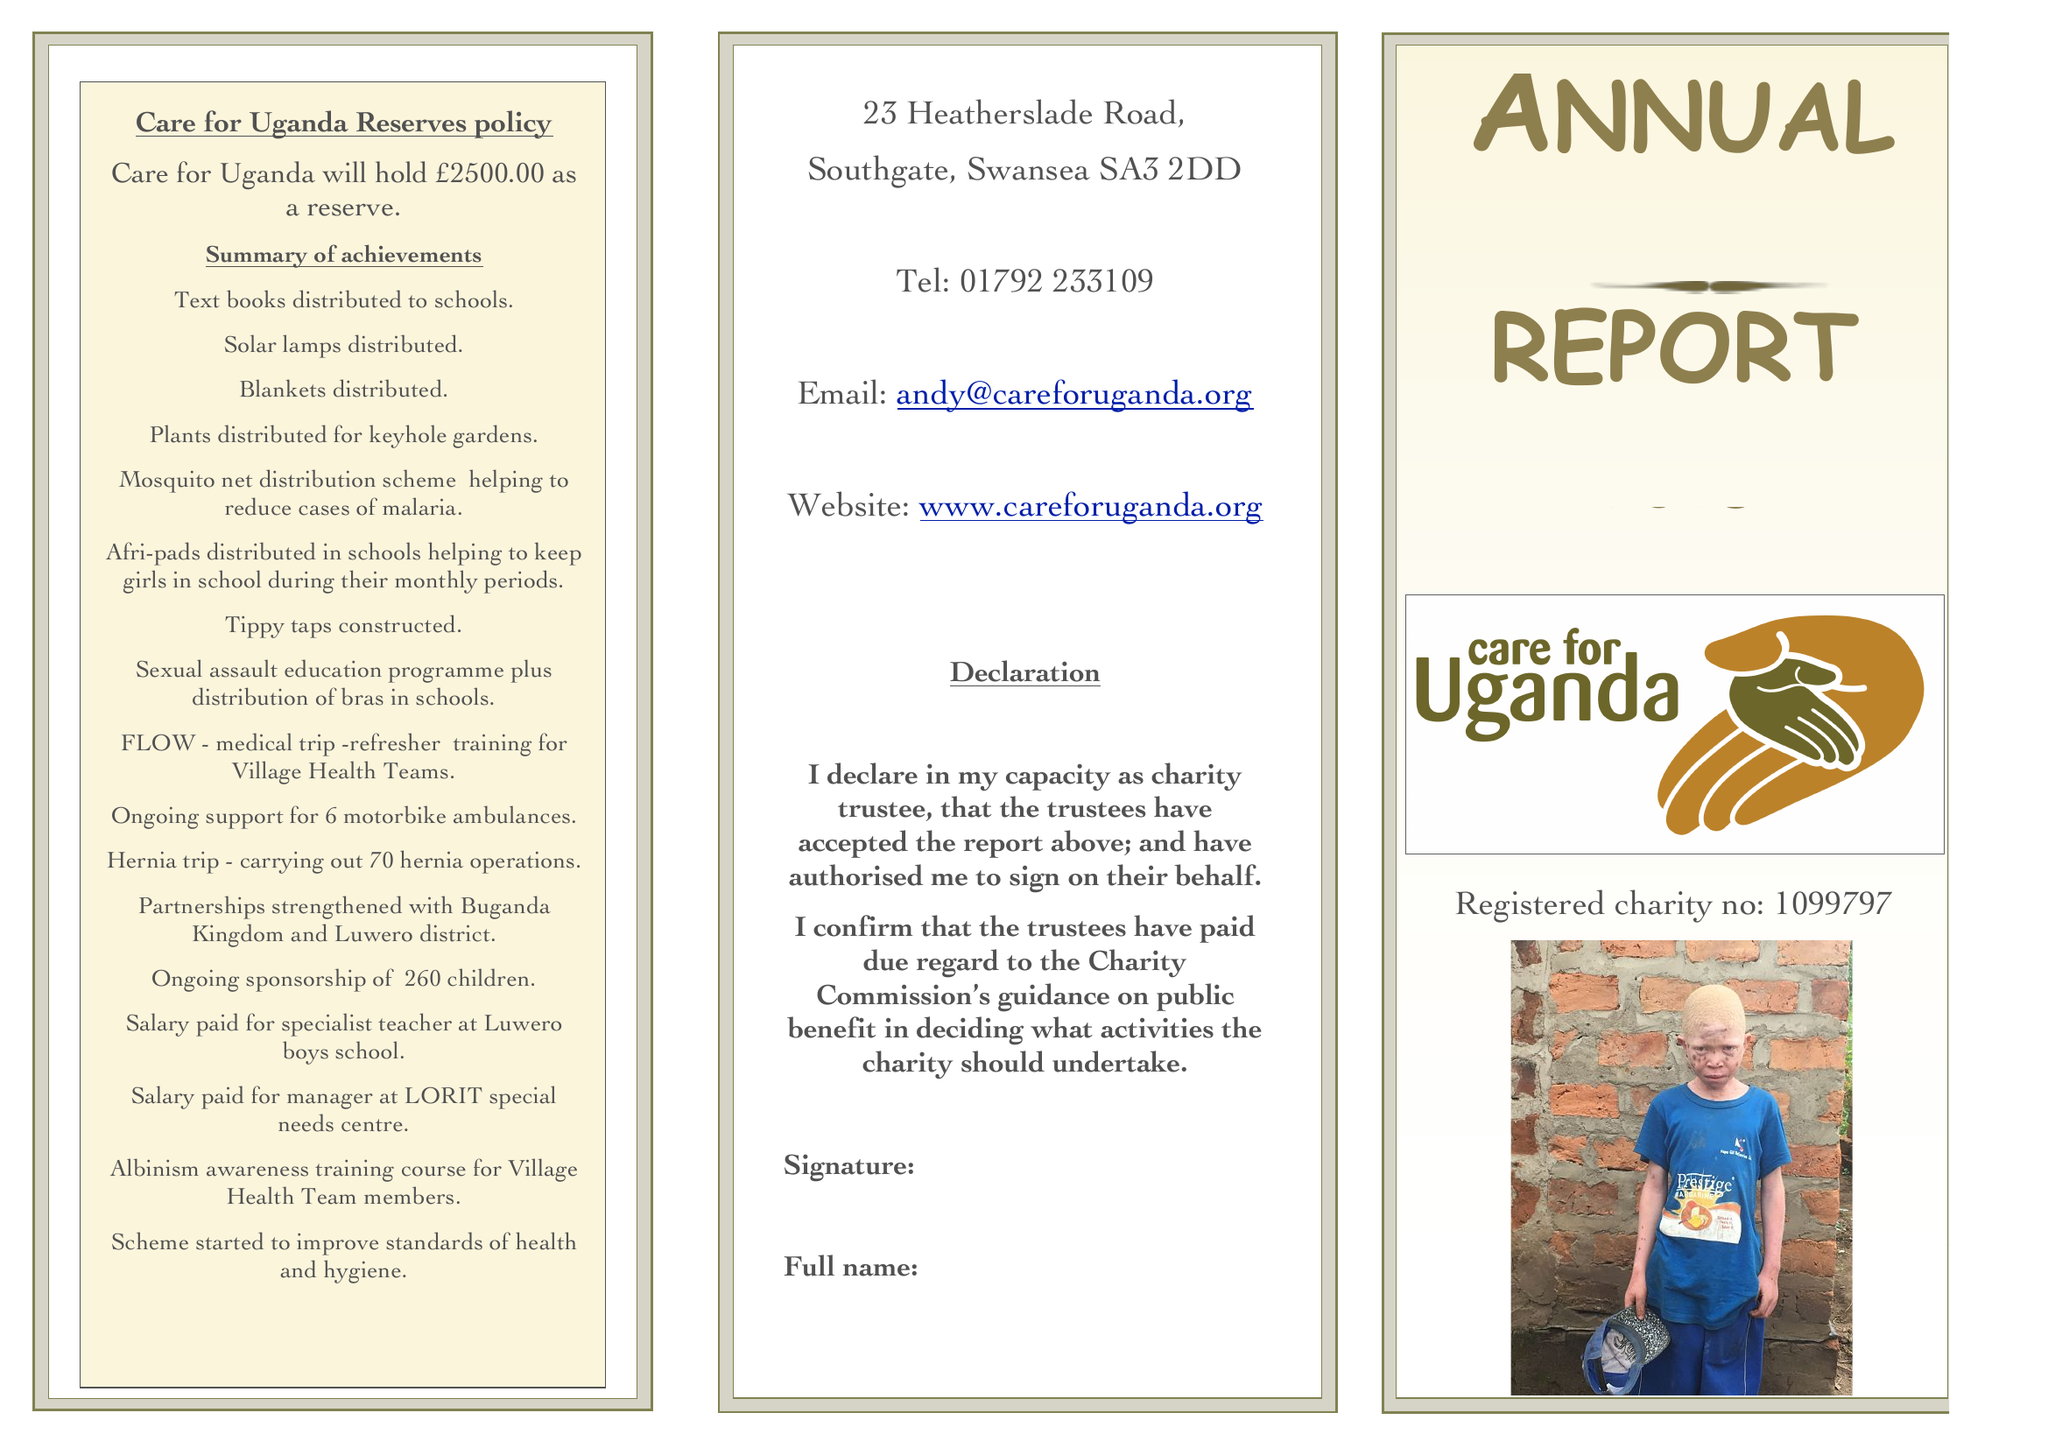What is the value for the income_annually_in_british_pounds?
Answer the question using a single word or phrase. 119588.00 